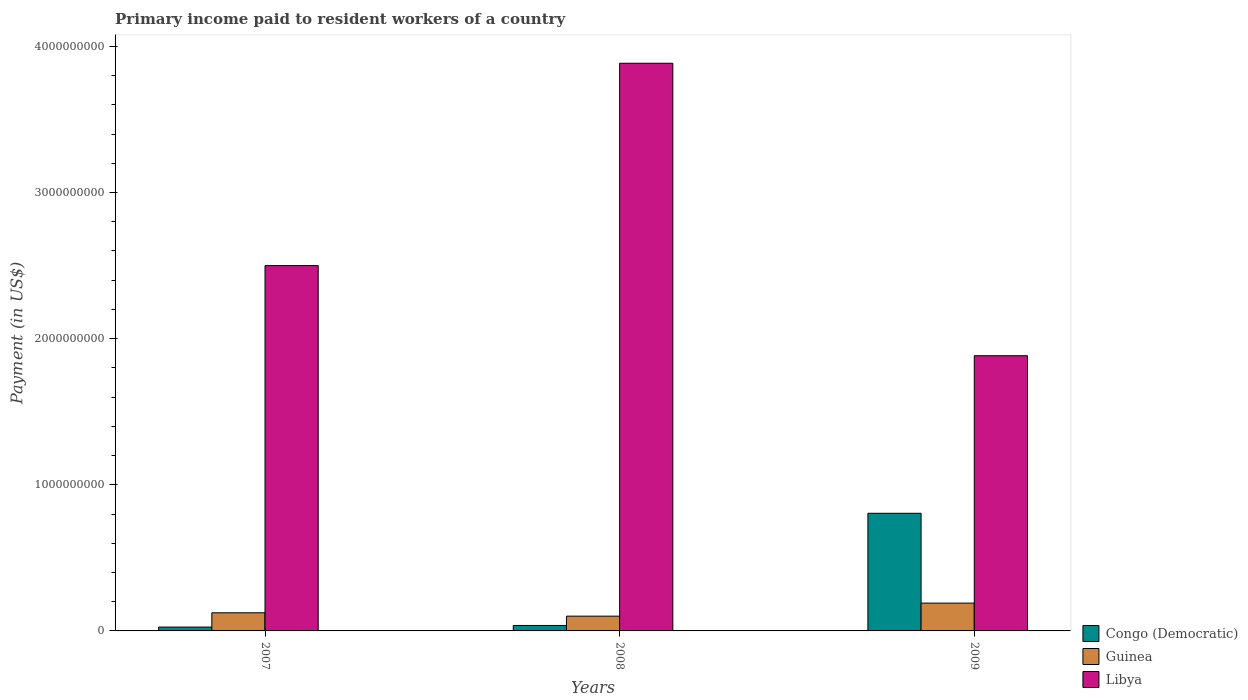How many bars are there on the 2nd tick from the left?
Ensure brevity in your answer.  3. What is the amount paid to workers in Libya in 2008?
Provide a succinct answer. 3.88e+09. Across all years, what is the maximum amount paid to workers in Guinea?
Make the answer very short. 1.90e+08. Across all years, what is the minimum amount paid to workers in Libya?
Offer a terse response. 1.88e+09. In which year was the amount paid to workers in Libya maximum?
Make the answer very short. 2008. What is the total amount paid to workers in Guinea in the graph?
Offer a very short reply. 4.16e+08. What is the difference between the amount paid to workers in Libya in 2007 and that in 2008?
Keep it short and to the point. -1.38e+09. What is the difference between the amount paid to workers in Congo (Democratic) in 2007 and the amount paid to workers in Guinea in 2008?
Keep it short and to the point. -7.46e+07. What is the average amount paid to workers in Libya per year?
Keep it short and to the point. 2.76e+09. In the year 2007, what is the difference between the amount paid to workers in Guinea and amount paid to workers in Libya?
Your answer should be very brief. -2.38e+09. What is the ratio of the amount paid to workers in Congo (Democratic) in 2007 to that in 2008?
Your response must be concise. 0.71. Is the amount paid to workers in Libya in 2007 less than that in 2008?
Your response must be concise. Yes. What is the difference between the highest and the second highest amount paid to workers in Libya?
Provide a succinct answer. 1.38e+09. What is the difference between the highest and the lowest amount paid to workers in Libya?
Make the answer very short. 2.00e+09. In how many years, is the amount paid to workers in Guinea greater than the average amount paid to workers in Guinea taken over all years?
Provide a succinct answer. 1. What does the 3rd bar from the left in 2007 represents?
Your answer should be very brief. Libya. What does the 3rd bar from the right in 2009 represents?
Your response must be concise. Congo (Democratic). Is it the case that in every year, the sum of the amount paid to workers in Congo (Democratic) and amount paid to workers in Guinea is greater than the amount paid to workers in Libya?
Provide a succinct answer. No. How many bars are there?
Keep it short and to the point. 9. What is the difference between two consecutive major ticks on the Y-axis?
Provide a short and direct response. 1.00e+09. Does the graph contain grids?
Your answer should be compact. No. Where does the legend appear in the graph?
Ensure brevity in your answer.  Bottom right. How are the legend labels stacked?
Keep it short and to the point. Vertical. What is the title of the graph?
Offer a very short reply. Primary income paid to resident workers of a country. What is the label or title of the X-axis?
Offer a very short reply. Years. What is the label or title of the Y-axis?
Make the answer very short. Payment (in US$). What is the Payment (in US$) in Congo (Democratic) in 2007?
Provide a succinct answer. 2.64e+07. What is the Payment (in US$) in Guinea in 2007?
Offer a terse response. 1.24e+08. What is the Payment (in US$) of Libya in 2007?
Give a very brief answer. 2.50e+09. What is the Payment (in US$) of Congo (Democratic) in 2008?
Your response must be concise. 3.74e+07. What is the Payment (in US$) of Guinea in 2008?
Provide a succinct answer. 1.01e+08. What is the Payment (in US$) of Libya in 2008?
Offer a terse response. 3.88e+09. What is the Payment (in US$) in Congo (Democratic) in 2009?
Your response must be concise. 8.05e+08. What is the Payment (in US$) of Guinea in 2009?
Your answer should be very brief. 1.90e+08. What is the Payment (in US$) of Libya in 2009?
Make the answer very short. 1.88e+09. Across all years, what is the maximum Payment (in US$) of Congo (Democratic)?
Keep it short and to the point. 8.05e+08. Across all years, what is the maximum Payment (in US$) in Guinea?
Give a very brief answer. 1.90e+08. Across all years, what is the maximum Payment (in US$) in Libya?
Your response must be concise. 3.88e+09. Across all years, what is the minimum Payment (in US$) in Congo (Democratic)?
Offer a terse response. 2.64e+07. Across all years, what is the minimum Payment (in US$) in Guinea?
Provide a short and direct response. 1.01e+08. Across all years, what is the minimum Payment (in US$) in Libya?
Provide a succinct answer. 1.88e+09. What is the total Payment (in US$) of Congo (Democratic) in the graph?
Your answer should be very brief. 8.69e+08. What is the total Payment (in US$) of Guinea in the graph?
Keep it short and to the point. 4.16e+08. What is the total Payment (in US$) in Libya in the graph?
Provide a short and direct response. 8.27e+09. What is the difference between the Payment (in US$) of Congo (Democratic) in 2007 and that in 2008?
Your response must be concise. -1.10e+07. What is the difference between the Payment (in US$) of Guinea in 2007 and that in 2008?
Make the answer very short. 2.31e+07. What is the difference between the Payment (in US$) of Libya in 2007 and that in 2008?
Offer a very short reply. -1.38e+09. What is the difference between the Payment (in US$) of Congo (Democratic) in 2007 and that in 2009?
Give a very brief answer. -7.79e+08. What is the difference between the Payment (in US$) in Guinea in 2007 and that in 2009?
Make the answer very short. -6.63e+07. What is the difference between the Payment (in US$) of Libya in 2007 and that in 2009?
Keep it short and to the point. 6.17e+08. What is the difference between the Payment (in US$) of Congo (Democratic) in 2008 and that in 2009?
Offer a very short reply. -7.68e+08. What is the difference between the Payment (in US$) of Guinea in 2008 and that in 2009?
Provide a short and direct response. -8.94e+07. What is the difference between the Payment (in US$) of Libya in 2008 and that in 2009?
Offer a very short reply. 2.00e+09. What is the difference between the Payment (in US$) in Congo (Democratic) in 2007 and the Payment (in US$) in Guinea in 2008?
Your answer should be very brief. -7.46e+07. What is the difference between the Payment (in US$) in Congo (Democratic) in 2007 and the Payment (in US$) in Libya in 2008?
Keep it short and to the point. -3.86e+09. What is the difference between the Payment (in US$) of Guinea in 2007 and the Payment (in US$) of Libya in 2008?
Provide a short and direct response. -3.76e+09. What is the difference between the Payment (in US$) in Congo (Democratic) in 2007 and the Payment (in US$) in Guinea in 2009?
Your answer should be compact. -1.64e+08. What is the difference between the Payment (in US$) of Congo (Democratic) in 2007 and the Payment (in US$) of Libya in 2009?
Your answer should be very brief. -1.86e+09. What is the difference between the Payment (in US$) of Guinea in 2007 and the Payment (in US$) of Libya in 2009?
Provide a short and direct response. -1.76e+09. What is the difference between the Payment (in US$) in Congo (Democratic) in 2008 and the Payment (in US$) in Guinea in 2009?
Your answer should be compact. -1.53e+08. What is the difference between the Payment (in US$) in Congo (Democratic) in 2008 and the Payment (in US$) in Libya in 2009?
Offer a terse response. -1.85e+09. What is the difference between the Payment (in US$) of Guinea in 2008 and the Payment (in US$) of Libya in 2009?
Offer a terse response. -1.78e+09. What is the average Payment (in US$) in Congo (Democratic) per year?
Provide a succinct answer. 2.90e+08. What is the average Payment (in US$) of Guinea per year?
Provide a short and direct response. 1.39e+08. What is the average Payment (in US$) of Libya per year?
Ensure brevity in your answer.  2.76e+09. In the year 2007, what is the difference between the Payment (in US$) of Congo (Democratic) and Payment (in US$) of Guinea?
Ensure brevity in your answer.  -9.77e+07. In the year 2007, what is the difference between the Payment (in US$) of Congo (Democratic) and Payment (in US$) of Libya?
Offer a very short reply. -2.47e+09. In the year 2007, what is the difference between the Payment (in US$) in Guinea and Payment (in US$) in Libya?
Give a very brief answer. -2.38e+09. In the year 2008, what is the difference between the Payment (in US$) in Congo (Democratic) and Payment (in US$) in Guinea?
Keep it short and to the point. -6.36e+07. In the year 2008, what is the difference between the Payment (in US$) of Congo (Democratic) and Payment (in US$) of Libya?
Your response must be concise. -3.85e+09. In the year 2008, what is the difference between the Payment (in US$) in Guinea and Payment (in US$) in Libya?
Ensure brevity in your answer.  -3.78e+09. In the year 2009, what is the difference between the Payment (in US$) of Congo (Democratic) and Payment (in US$) of Guinea?
Ensure brevity in your answer.  6.15e+08. In the year 2009, what is the difference between the Payment (in US$) of Congo (Democratic) and Payment (in US$) of Libya?
Your response must be concise. -1.08e+09. In the year 2009, what is the difference between the Payment (in US$) of Guinea and Payment (in US$) of Libya?
Make the answer very short. -1.69e+09. What is the ratio of the Payment (in US$) of Congo (Democratic) in 2007 to that in 2008?
Provide a succinct answer. 0.71. What is the ratio of the Payment (in US$) in Guinea in 2007 to that in 2008?
Give a very brief answer. 1.23. What is the ratio of the Payment (in US$) in Libya in 2007 to that in 2008?
Offer a terse response. 0.64. What is the ratio of the Payment (in US$) in Congo (Democratic) in 2007 to that in 2009?
Your answer should be very brief. 0.03. What is the ratio of the Payment (in US$) of Guinea in 2007 to that in 2009?
Offer a terse response. 0.65. What is the ratio of the Payment (in US$) in Libya in 2007 to that in 2009?
Ensure brevity in your answer.  1.33. What is the ratio of the Payment (in US$) in Congo (Democratic) in 2008 to that in 2009?
Keep it short and to the point. 0.05. What is the ratio of the Payment (in US$) of Guinea in 2008 to that in 2009?
Make the answer very short. 0.53. What is the ratio of the Payment (in US$) in Libya in 2008 to that in 2009?
Your answer should be very brief. 2.06. What is the difference between the highest and the second highest Payment (in US$) in Congo (Democratic)?
Offer a terse response. 7.68e+08. What is the difference between the highest and the second highest Payment (in US$) of Guinea?
Give a very brief answer. 6.63e+07. What is the difference between the highest and the second highest Payment (in US$) of Libya?
Provide a short and direct response. 1.38e+09. What is the difference between the highest and the lowest Payment (in US$) in Congo (Democratic)?
Provide a succinct answer. 7.79e+08. What is the difference between the highest and the lowest Payment (in US$) of Guinea?
Provide a succinct answer. 8.94e+07. What is the difference between the highest and the lowest Payment (in US$) of Libya?
Give a very brief answer. 2.00e+09. 